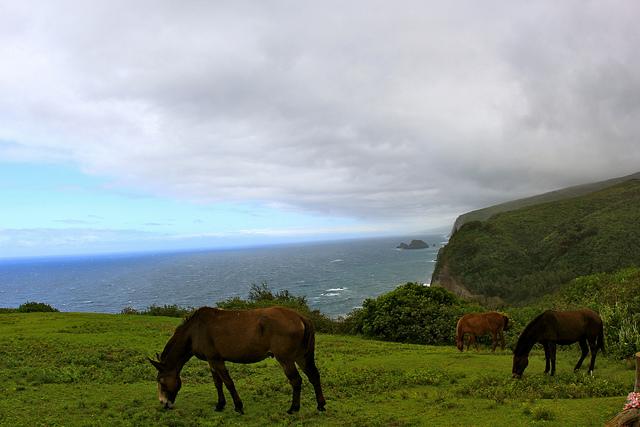What color are the grass?
Keep it brief. Green. How many horses are there?
Be succinct. 3. Are the animals grazing?
Give a very brief answer. Yes. What is the grass eating?
Keep it brief. Nothing. What color are the clouds?
Answer briefly. Gray. How many horses in the picture?
Answer briefly. 3. Is this an elephant farm?
Write a very short answer. No. What kind of animals are these?
Quick response, please. Horses. Is the sky clear?
Be succinct. No. Where was this taken?
Answer briefly. Ireland. What kind of animal is this?
Write a very short answer. Horse. Is the horse lonely?
Keep it brief. No. Is the horse saddled?
Quick response, please. No. 